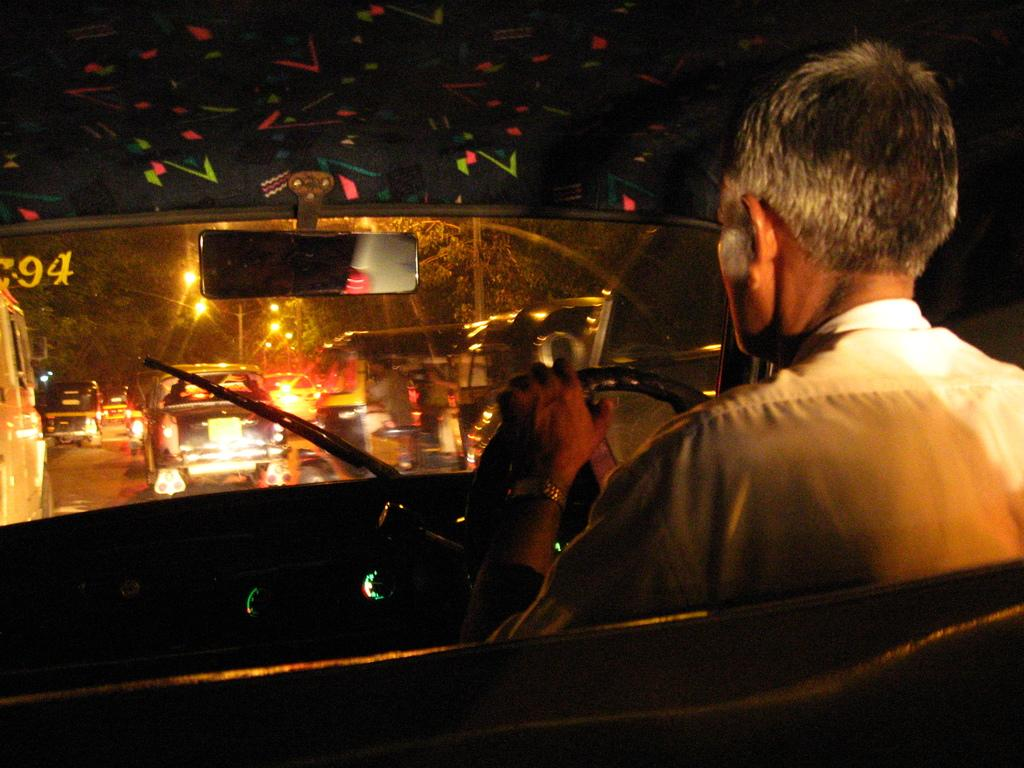What is the setting of the image? The image shows the internal view of a car. What is the person in the image doing? There is a person driving the car in the image. Where is the market located in the image? There is no market present in the image; it shows the internal view of a car with a person driving. 